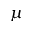<formula> <loc_0><loc_0><loc_500><loc_500>\mu</formula> 